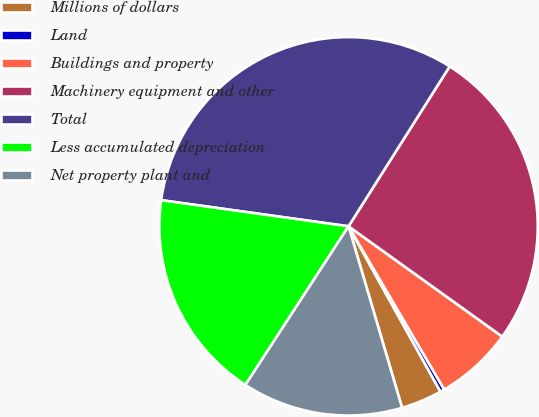Convert chart. <chart><loc_0><loc_0><loc_500><loc_500><pie_chart><fcel>Millions of dollars<fcel>Land<fcel>Buildings and property<fcel>Machinery equipment and other<fcel>Total<fcel>Less accumulated depreciation<fcel>Net property plant and<nl><fcel>3.51%<fcel>0.37%<fcel>6.65%<fcel>25.93%<fcel>31.77%<fcel>18.03%<fcel>13.74%<nl></chart> 